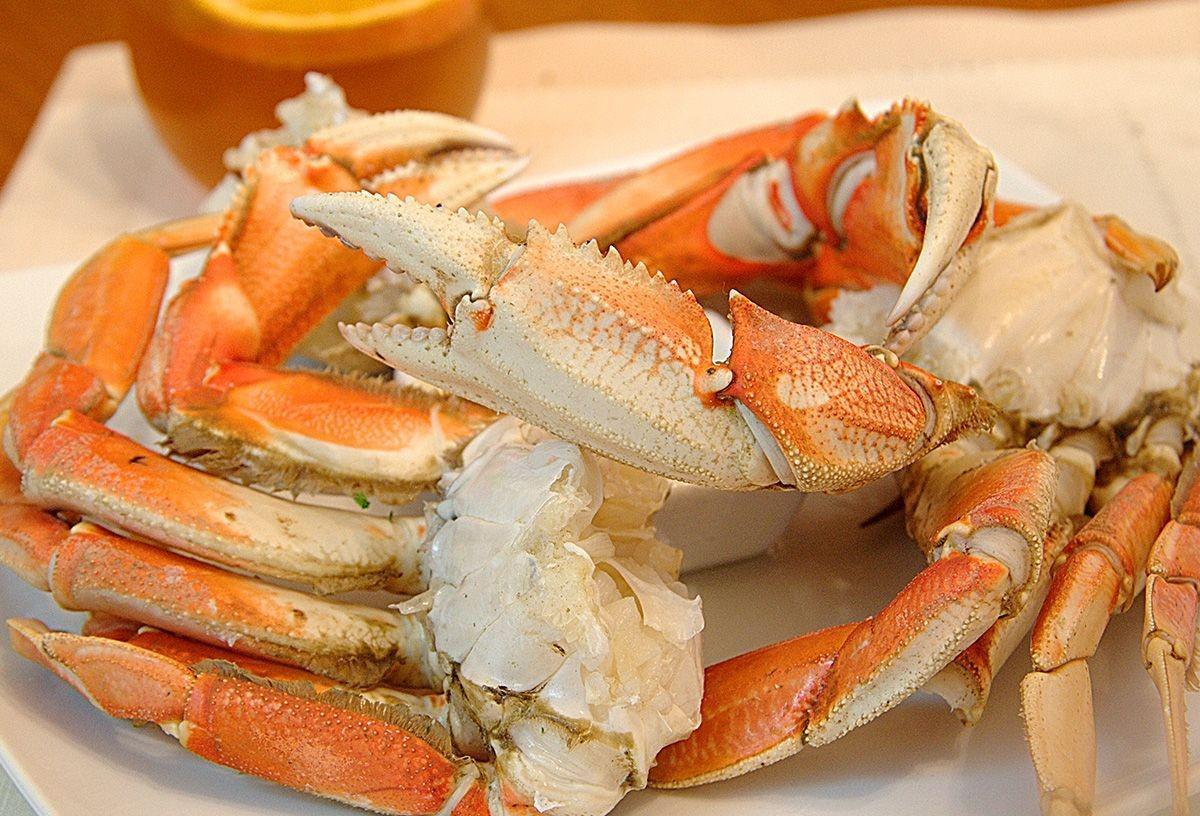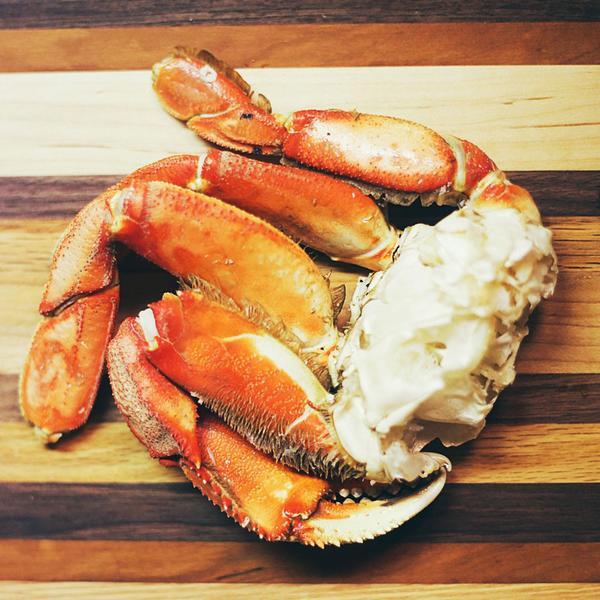The first image is the image on the left, the second image is the image on the right. Examine the images to the left and right. Is the description "there are two snow crab clusters on a white round plate" accurate? Answer yes or no. No. The first image is the image on the left, the second image is the image on the right. Considering the images on both sides, is "One image shows long red crab legs connected by whitish meat served on a round white plate." valid? Answer yes or no. No. 